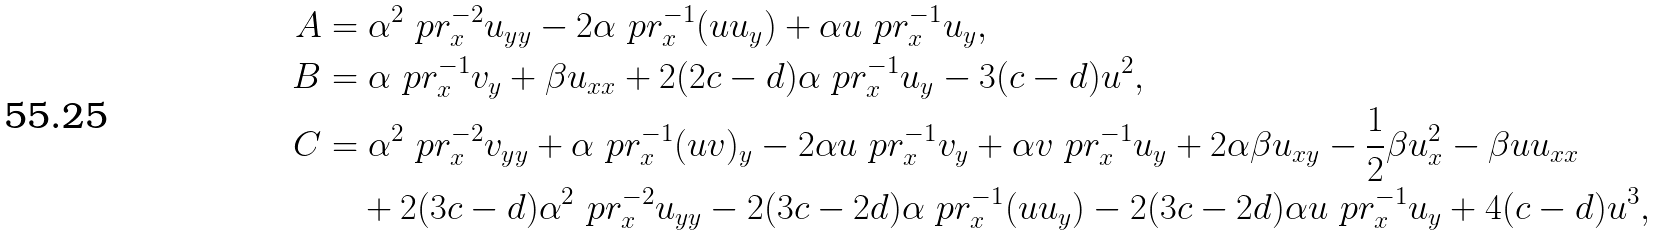Convert formula to latex. <formula><loc_0><loc_0><loc_500><loc_500>A & = \alpha ^ { 2 } \ p r _ { x } ^ { - 2 } u _ { y y } - 2 \alpha \ p r _ { x } ^ { - 1 } ( u u _ { y } ) + \alpha u \ p r _ { x } ^ { - 1 } u _ { y } , \\ B & = \alpha \ p r _ { x } ^ { - 1 } v _ { y } + \beta u _ { x x } + 2 ( 2 c - d ) \alpha \ p r _ { x } ^ { - 1 } u _ { y } - 3 ( c - d ) u ^ { 2 } , \\ C & = \alpha ^ { 2 } \ p r _ { x } ^ { - 2 } v _ { y y } + \alpha \ p r _ { x } ^ { - 1 } ( u v ) _ { y } - 2 \alpha u \ p r _ { x } ^ { - 1 } v _ { y } + \alpha v \ p r _ { x } ^ { - 1 } u _ { y } + 2 \alpha \beta u _ { x y } - \frac { 1 } { 2 } \beta u _ { x } ^ { 2 } - \beta u u _ { x x } \\ & \quad + 2 ( 3 c - d ) \alpha ^ { 2 } \ p r _ { x } ^ { - 2 } u _ { y y } - 2 ( 3 c - 2 d ) \alpha \ p r _ { x } ^ { - 1 } ( u u _ { y } ) - 2 ( 3 c - 2 d ) \alpha u \ p r _ { x } ^ { - 1 } u _ { y } + 4 ( c - d ) u ^ { 3 } ,</formula> 